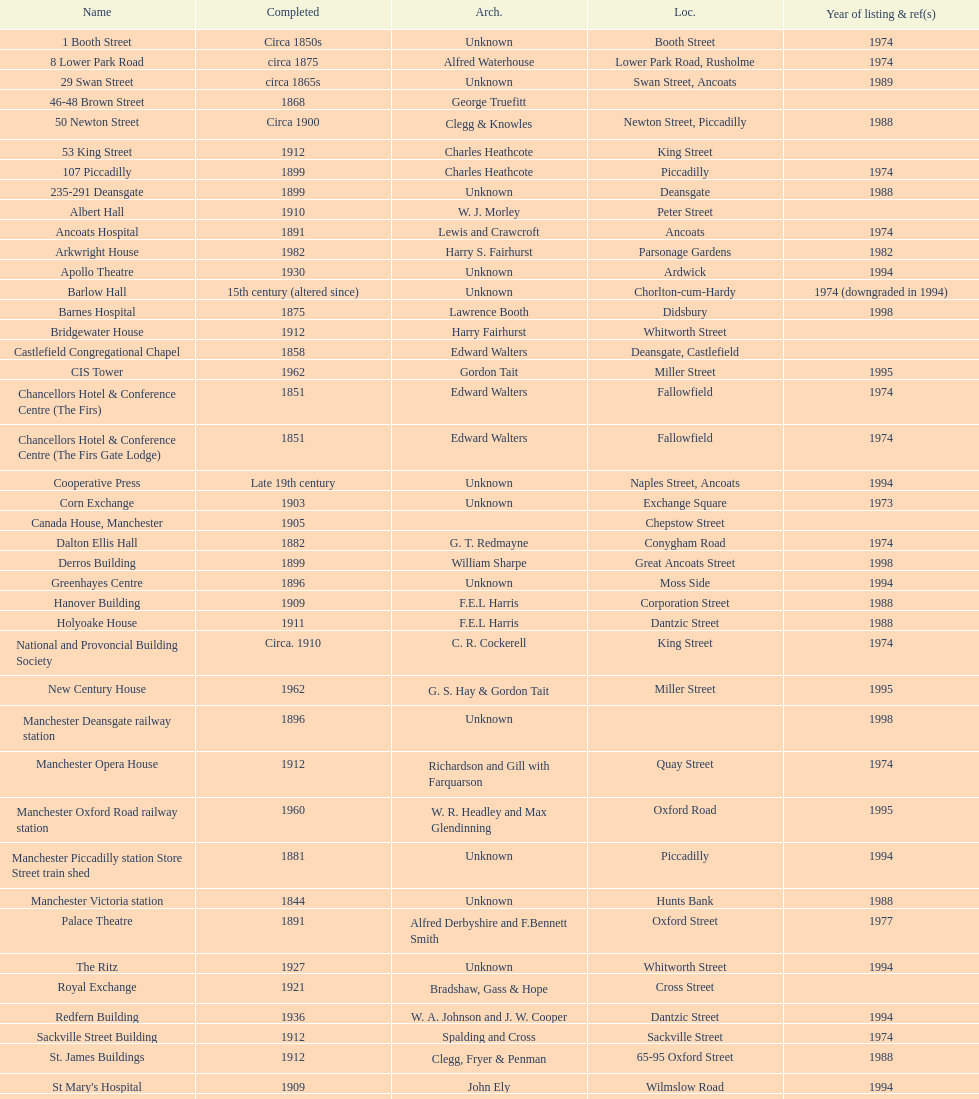How many buildings has the same year of listing as 1974? 15. 